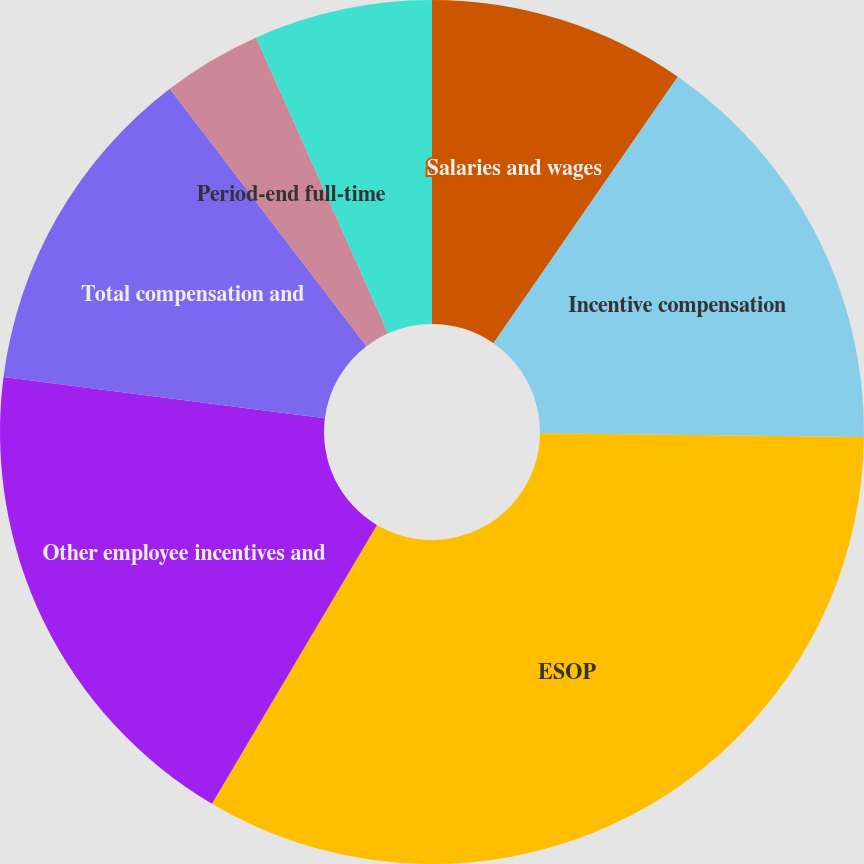<chart> <loc_0><loc_0><loc_500><loc_500><pie_chart><fcel>Salaries and wages<fcel>Incentive compensation<fcel>ESOP<fcel>Other employee incentives and<fcel>Total compensation and<fcel>Period-end full-time<fcel>Average full-time equivalent<nl><fcel>9.63%<fcel>15.55%<fcel>33.32%<fcel>18.52%<fcel>12.59%<fcel>3.71%<fcel>6.67%<nl></chart> 